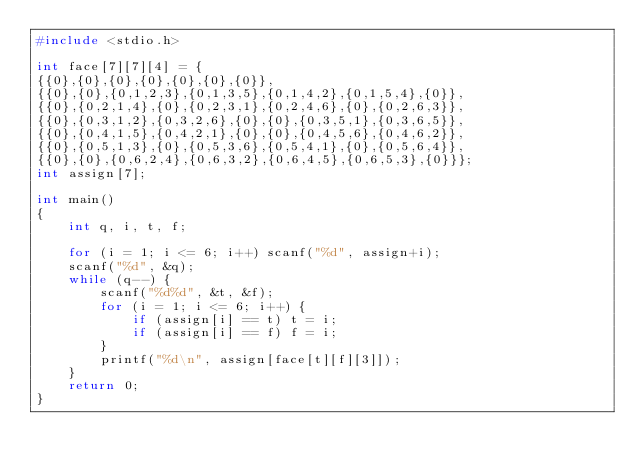Convert code to text. <code><loc_0><loc_0><loc_500><loc_500><_C_>#include <stdio.h>

int face[7][7][4] = {
{{0},{0},{0},{0},{0},{0},{0}},
{{0},{0},{0,1,2,3},{0,1,3,5},{0,1,4,2},{0,1,5,4},{0}},
{{0},{0,2,1,4},{0},{0,2,3,1},{0,2,4,6},{0},{0,2,6,3}},
{{0},{0,3,1,2},{0,3,2,6},{0},{0},{0,3,5,1},{0,3,6,5}},
{{0},{0,4,1,5},{0,4,2,1},{0},{0},{0,4,5,6},{0,4,6,2}},
{{0},{0,5,1,3},{0},{0,5,3,6},{0,5,4,1},{0},{0,5,6,4}},
{{0},{0},{0,6,2,4},{0,6,3,2},{0,6,4,5},{0,6,5,3},{0}}};
int assign[7];

int main()
{
	int q, i, t, f;

	for (i = 1; i <= 6; i++) scanf("%d", assign+i);
	scanf("%d", &q);
	while (q--) {
		scanf("%d%d", &t, &f);
		for (i = 1; i <= 6; i++) {
			if (assign[i] == t) t = i;
			if (assign[i] == f) f = i;
		}
		printf("%d\n", assign[face[t][f][3]]);
	}
	return 0;
}
</code> 